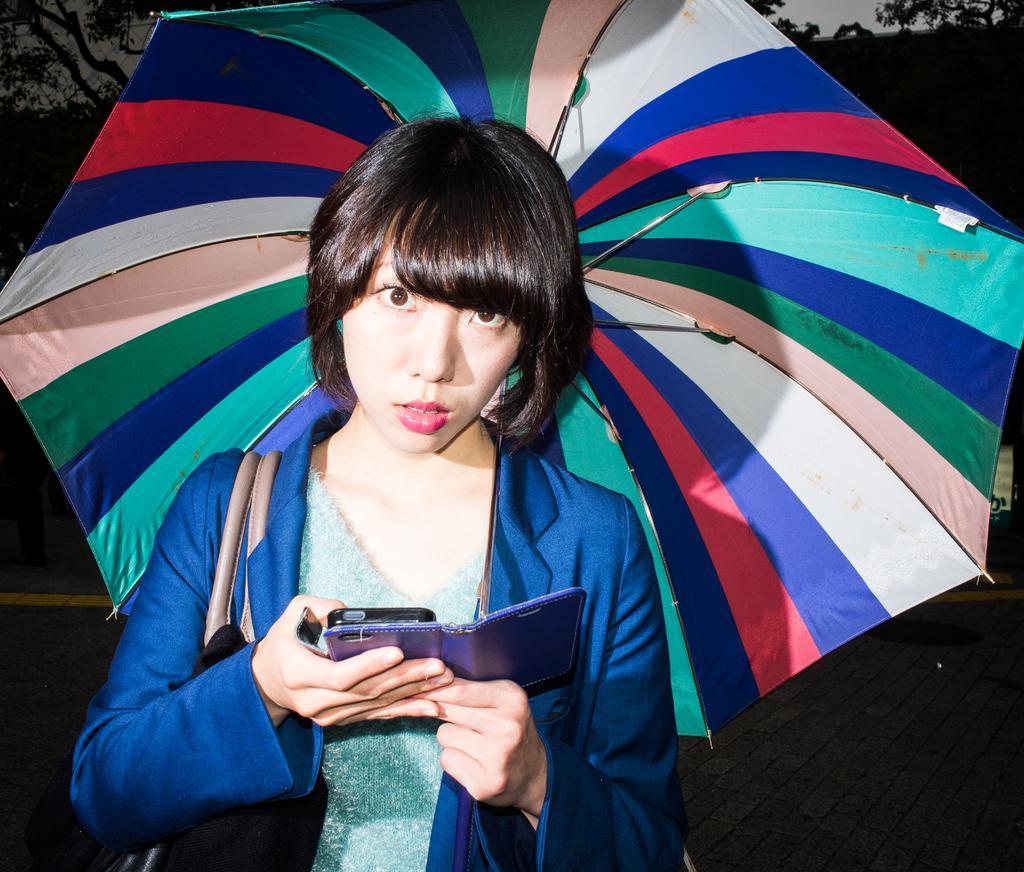Describe this image in one or two sentences. In the picture,there is a woman. She is operating the mobile phone,she is also holding a colorful umbrella and she is standing on a wooden surface. 